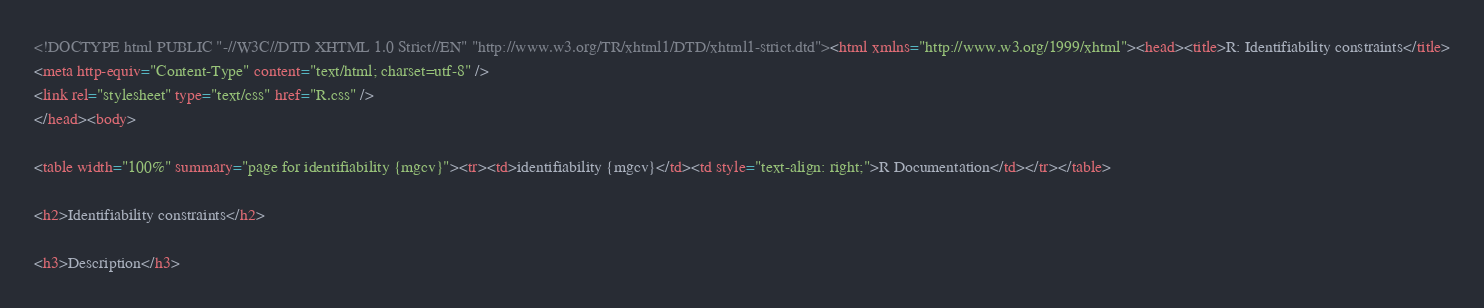Convert code to text. <code><loc_0><loc_0><loc_500><loc_500><_HTML_><!DOCTYPE html PUBLIC "-//W3C//DTD XHTML 1.0 Strict//EN" "http://www.w3.org/TR/xhtml1/DTD/xhtml1-strict.dtd"><html xmlns="http://www.w3.org/1999/xhtml"><head><title>R: Identifiability constraints</title>
<meta http-equiv="Content-Type" content="text/html; charset=utf-8" />
<link rel="stylesheet" type="text/css" href="R.css" />
</head><body>

<table width="100%" summary="page for identifiability {mgcv}"><tr><td>identifiability {mgcv}</td><td style="text-align: right;">R Documentation</td></tr></table>

<h2>Identifiability constraints</h2>

<h3>Description</h3>
</code> 